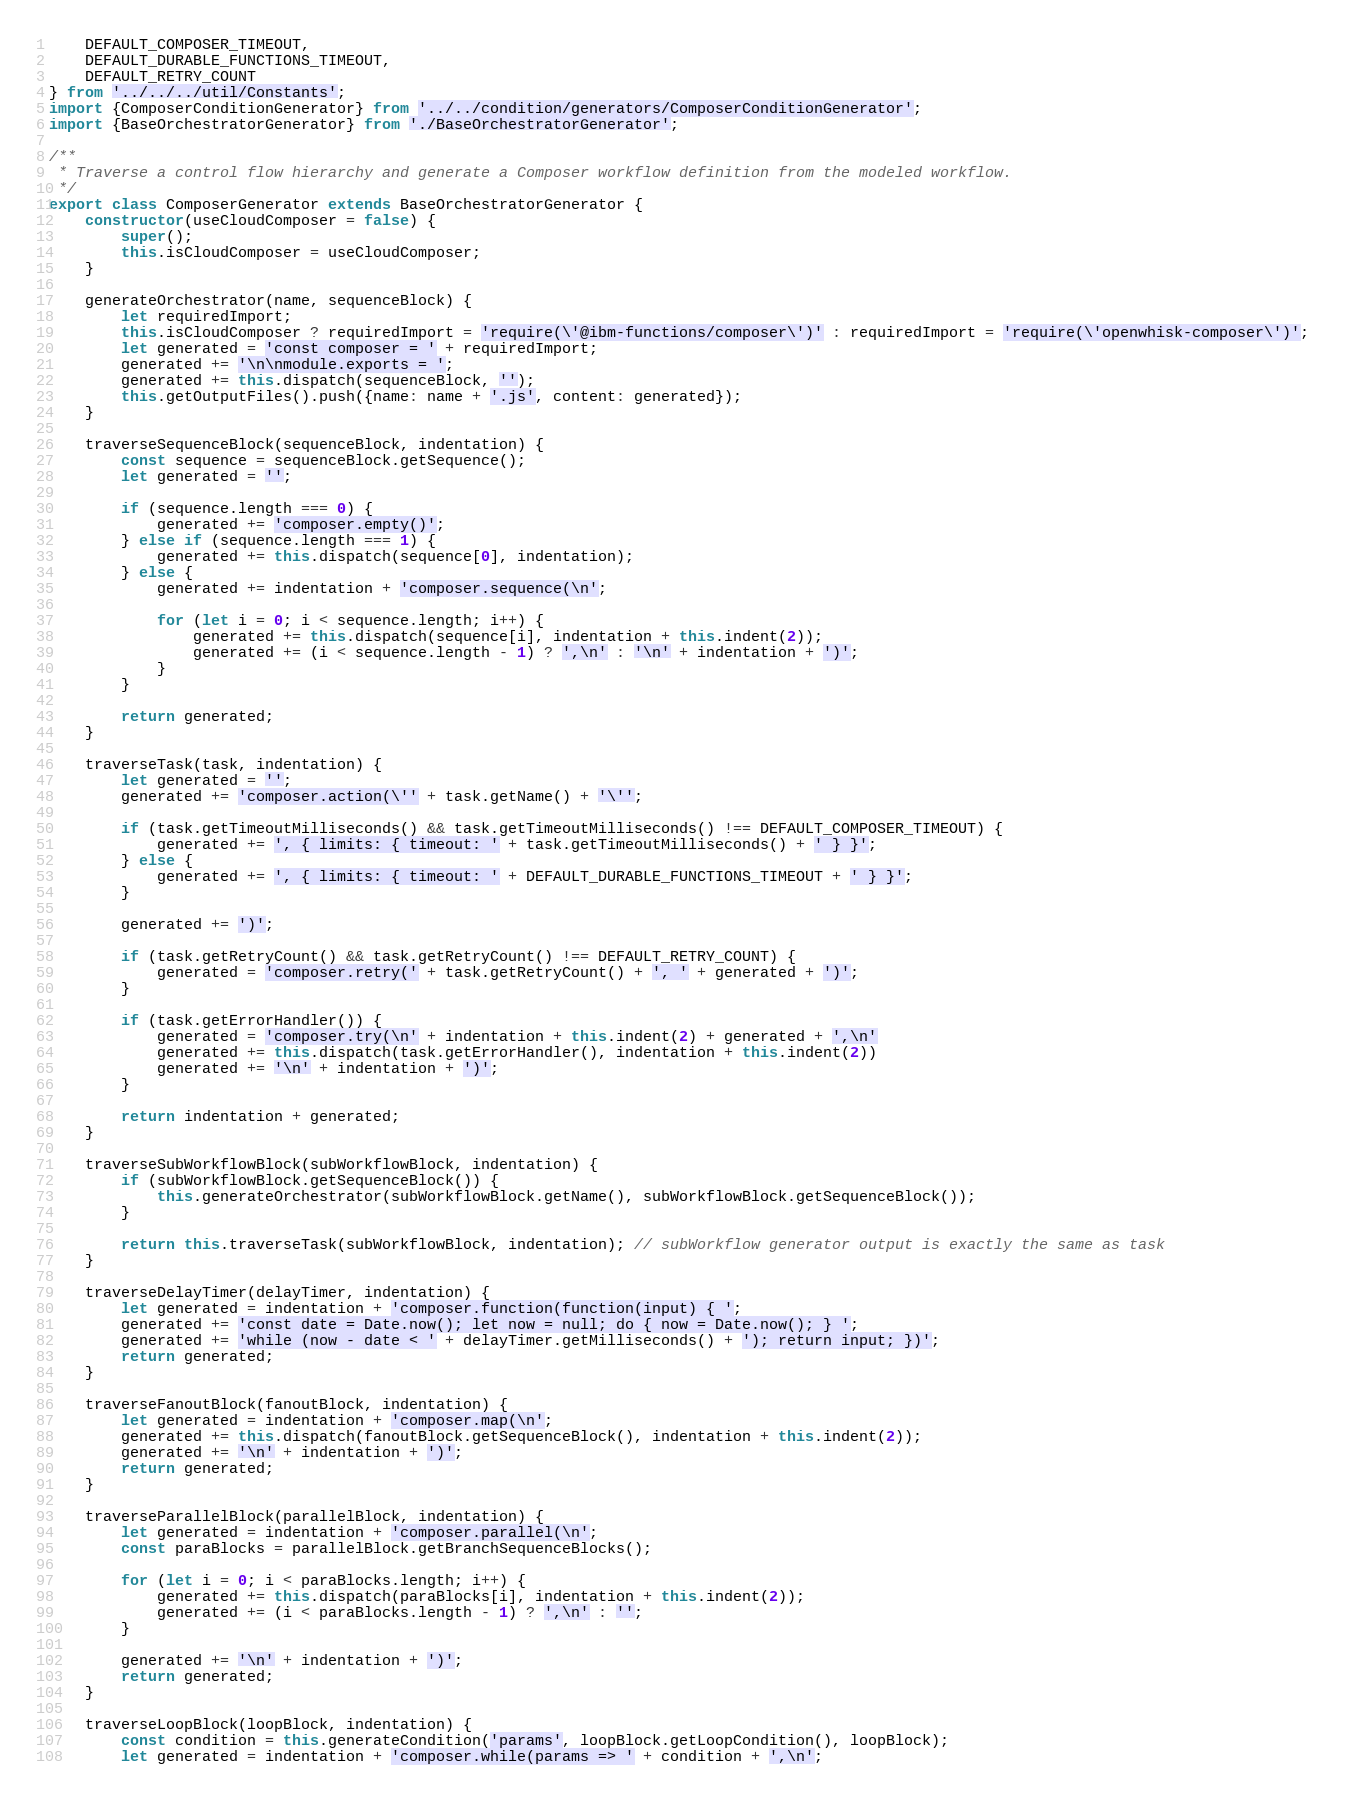<code> <loc_0><loc_0><loc_500><loc_500><_JavaScript_>    DEFAULT_COMPOSER_TIMEOUT,
    DEFAULT_DURABLE_FUNCTIONS_TIMEOUT,
    DEFAULT_RETRY_COUNT
} from '../../../util/Constants';
import {ComposerConditionGenerator} from '../../condition/generators/ComposerConditionGenerator';
import {BaseOrchestratorGenerator} from './BaseOrchestratorGenerator';

/**
 * Traverse a control flow hierarchy and generate a Composer workflow definition from the modeled workflow.
 */
export class ComposerGenerator extends BaseOrchestratorGenerator {
    constructor(useCloudComposer = false) {
        super();
        this.isCloudComposer = useCloudComposer;
    }

    generateOrchestrator(name, sequenceBlock) {
        let requiredImport;
        this.isCloudComposer ? requiredImport = 'require(\'@ibm-functions/composer\')' : requiredImport = 'require(\'openwhisk-composer\')';
        let generated = 'const composer = ' + requiredImport;
        generated += '\n\nmodule.exports = ';
        generated += this.dispatch(sequenceBlock, '');
        this.getOutputFiles().push({name: name + '.js', content: generated});
    }

    traverseSequenceBlock(sequenceBlock, indentation) {
        const sequence = sequenceBlock.getSequence();
        let generated = '';

        if (sequence.length === 0) {
            generated += 'composer.empty()';
        } else if (sequence.length === 1) {
            generated += this.dispatch(sequence[0], indentation);
        } else {
            generated += indentation + 'composer.sequence(\n';

            for (let i = 0; i < sequence.length; i++) {
                generated += this.dispatch(sequence[i], indentation + this.indent(2));
                generated += (i < sequence.length - 1) ? ',\n' : '\n' + indentation + ')';
            }
        }

        return generated;
    }

    traverseTask(task, indentation) {
        let generated = '';
        generated += 'composer.action(\'' + task.getName() + '\'';

        if (task.getTimeoutMilliseconds() && task.getTimeoutMilliseconds() !== DEFAULT_COMPOSER_TIMEOUT) {
            generated += ', { limits: { timeout: ' + task.getTimeoutMilliseconds() + ' } }';
        } else {
            generated += ', { limits: { timeout: ' + DEFAULT_DURABLE_FUNCTIONS_TIMEOUT + ' } }';
        }

        generated += ')';

        if (task.getRetryCount() && task.getRetryCount() !== DEFAULT_RETRY_COUNT) {
            generated = 'composer.retry(' + task.getRetryCount() + ', ' + generated + ')';
        }

        if (task.getErrorHandler()) {
            generated = 'composer.try(\n' + indentation + this.indent(2) + generated + ',\n'
            generated += this.dispatch(task.getErrorHandler(), indentation + this.indent(2))
            generated += '\n' + indentation + ')';
        }

        return indentation + generated;
    }

    traverseSubWorkflowBlock(subWorkflowBlock, indentation) {
        if (subWorkflowBlock.getSequenceBlock()) {
            this.generateOrchestrator(subWorkflowBlock.getName(), subWorkflowBlock.getSequenceBlock());
        }

        return this.traverseTask(subWorkflowBlock, indentation); // subWorkflow generator output is exactly the same as task
    }

    traverseDelayTimer(delayTimer, indentation) {
        let generated = indentation + 'composer.function(function(input) { ';
        generated += 'const date = Date.now(); let now = null; do { now = Date.now(); } ';
        generated += 'while (now - date < ' + delayTimer.getMilliseconds() + '); return input; })';
        return generated;
    }

    traverseFanoutBlock(fanoutBlock, indentation) {
        let generated = indentation + 'composer.map(\n';
        generated += this.dispatch(fanoutBlock.getSequenceBlock(), indentation + this.indent(2));
        generated += '\n' + indentation + ')';
        return generated;
    }

    traverseParallelBlock(parallelBlock, indentation) {
        let generated = indentation + 'composer.parallel(\n';
        const paraBlocks = parallelBlock.getBranchSequenceBlocks();

        for (let i = 0; i < paraBlocks.length; i++) {
            generated += this.dispatch(paraBlocks[i], indentation + this.indent(2));
            generated += (i < paraBlocks.length - 1) ? ',\n' : '';
        }

        generated += '\n' + indentation + ')';
        return generated;
    }

    traverseLoopBlock(loopBlock, indentation) {
        const condition = this.generateCondition('params', loopBlock.getLoopCondition(), loopBlock);
        let generated = indentation + 'composer.while(params => ' + condition + ',\n';</code> 